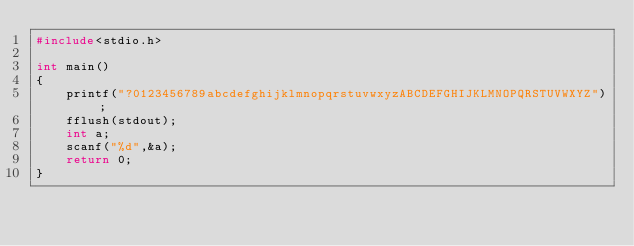<code> <loc_0><loc_0><loc_500><loc_500><_C_>#include<stdio.h>

int main()
{
    printf("?0123456789abcdefghijklmnopqrstuvwxyzABCDEFGHIJKLMNOPQRSTUVWXYZ");
    fflush(stdout);
    int a;
    scanf("%d",&a);
    return 0;
}</code> 